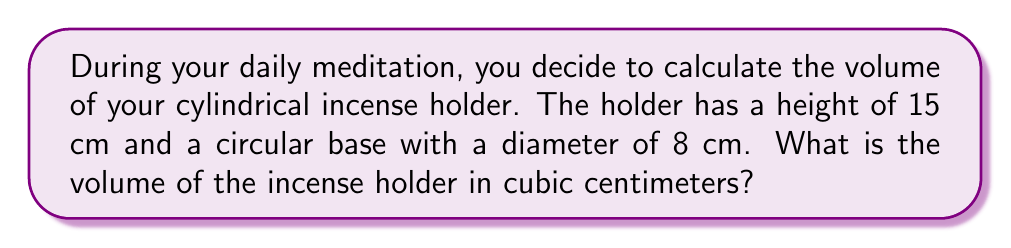Teach me how to tackle this problem. To find the volume of a cylinder, we use the formula:

$$V = \pi r^2 h$$

Where:
$V$ = volume
$r$ = radius of the base
$h$ = height of the cylinder

Step 1: Determine the radius
The diameter is 8 cm, so the radius is half of that:
$r = 8 \div 2 = 4$ cm

Step 2: Apply the formula
$$\begin{align*}
V &= \pi r^2 h \\
&= \pi (4 \text{ cm})^2 (15 \text{ cm}) \\
&= \pi (16 \text{ cm}^2) (15 \text{ cm}) \\
&= 240\pi \text{ cm}^3
\end{align*}$$

Step 3: Calculate the final value
$240\pi \approx 753.98 \text{ cm}^3$

Therefore, the volume of the incense holder is approximately 754 cubic centimeters.
Answer: $754 \text{ cm}^3$ 